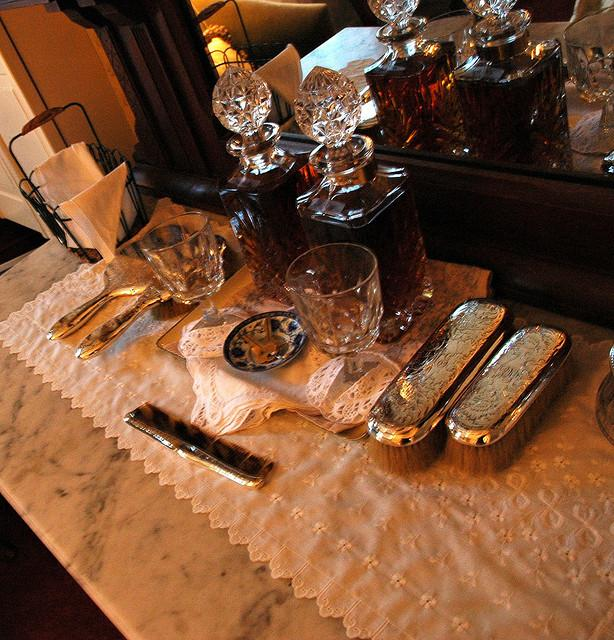What is most likely in the glass with the round top?

Choices:
A) plasma
B) alcohol
C) tears
D) honey alcohol 